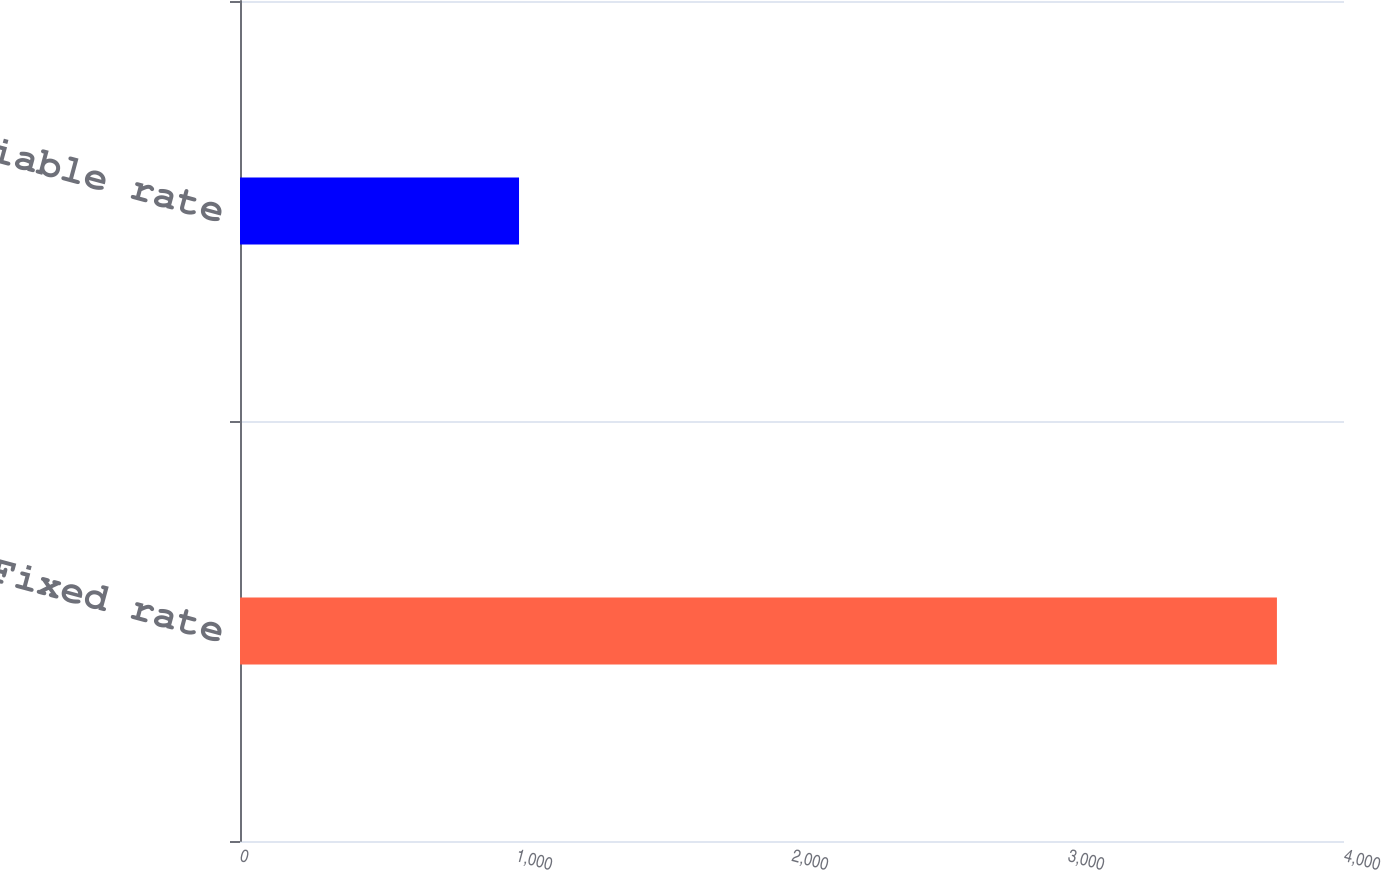Convert chart. <chart><loc_0><loc_0><loc_500><loc_500><bar_chart><fcel>Fixed rate<fcel>Variable rate<nl><fcel>3757<fcel>1011<nl></chart> 